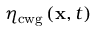Convert formula to latex. <formula><loc_0><loc_0><loc_500><loc_500>\eta _ { c w g } \left ( x , t \right )</formula> 